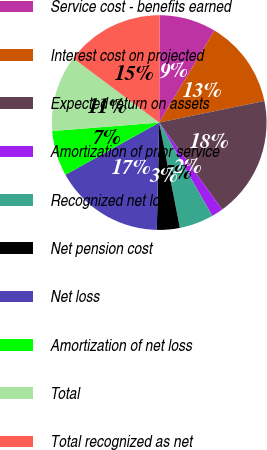Convert chart to OTSL. <chart><loc_0><loc_0><loc_500><loc_500><pie_chart><fcel>Service cost - benefits earned<fcel>Interest cost on projected<fcel>Expected return on assets<fcel>Amortization of prior service<fcel>Recognized net loss<fcel>Net pension cost<fcel>Net loss<fcel>Amortization of net loss<fcel>Total<fcel>Total recognized as net<nl><fcel>8.53%<fcel>13.17%<fcel>18.25%<fcel>1.75%<fcel>5.14%<fcel>3.44%<fcel>16.56%<fcel>6.83%<fcel>11.47%<fcel>14.86%<nl></chart> 